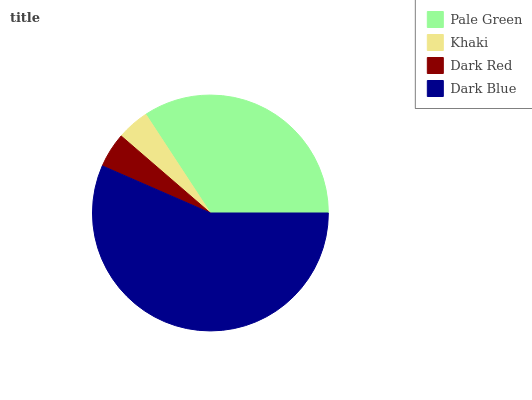Is Khaki the minimum?
Answer yes or no. Yes. Is Dark Blue the maximum?
Answer yes or no. Yes. Is Dark Red the minimum?
Answer yes or no. No. Is Dark Red the maximum?
Answer yes or no. No. Is Dark Red greater than Khaki?
Answer yes or no. Yes. Is Khaki less than Dark Red?
Answer yes or no. Yes. Is Khaki greater than Dark Red?
Answer yes or no. No. Is Dark Red less than Khaki?
Answer yes or no. No. Is Pale Green the high median?
Answer yes or no. Yes. Is Dark Red the low median?
Answer yes or no. Yes. Is Khaki the high median?
Answer yes or no. No. Is Dark Blue the low median?
Answer yes or no. No. 